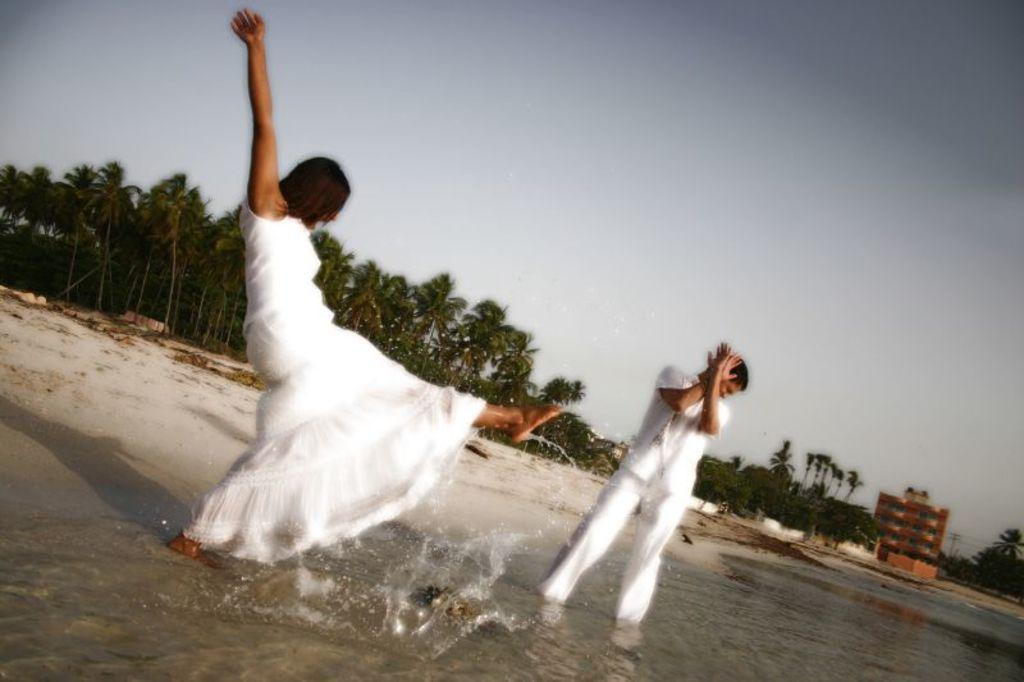What are the people in the image doing? The people in the image are standing on water. What can be seen in the background of the image? There is a building and trees in the background of the image. What is visible in the sky in the image? The sky is visible in the background of the image. How many spiders are crawling on the father's arm in the image? There is no father or spiders present in the image. 